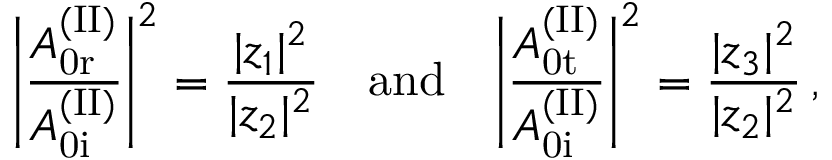<formula> <loc_0><loc_0><loc_500><loc_500>\left | \frac { A _ { 0 r } ^ { ( I I ) } } { A _ { 0 i } ^ { ( I I ) } } \right | ^ { 2 } = \frac { | z _ { 1 } | ^ { 2 } } { | z _ { 2 } | ^ { 2 } } \quad a n d \quad \left | \frac { A _ { 0 t } ^ { ( I I ) } } { A _ { 0 i } ^ { ( I I ) } } \right | ^ { 2 } = \frac { | z _ { 3 } | ^ { 2 } } { | z _ { 2 } | ^ { 2 } } \, ,</formula> 